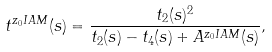Convert formula to latex. <formula><loc_0><loc_0><loc_500><loc_500>t ^ { z _ { 0 } I A M } ( s ) = \frac { t _ { 2 } ( s ) ^ { 2 } } { t _ { 2 } ( s ) - t _ { 4 } ( s ) + A ^ { z _ { 0 } I A M } ( s ) } ,</formula> 